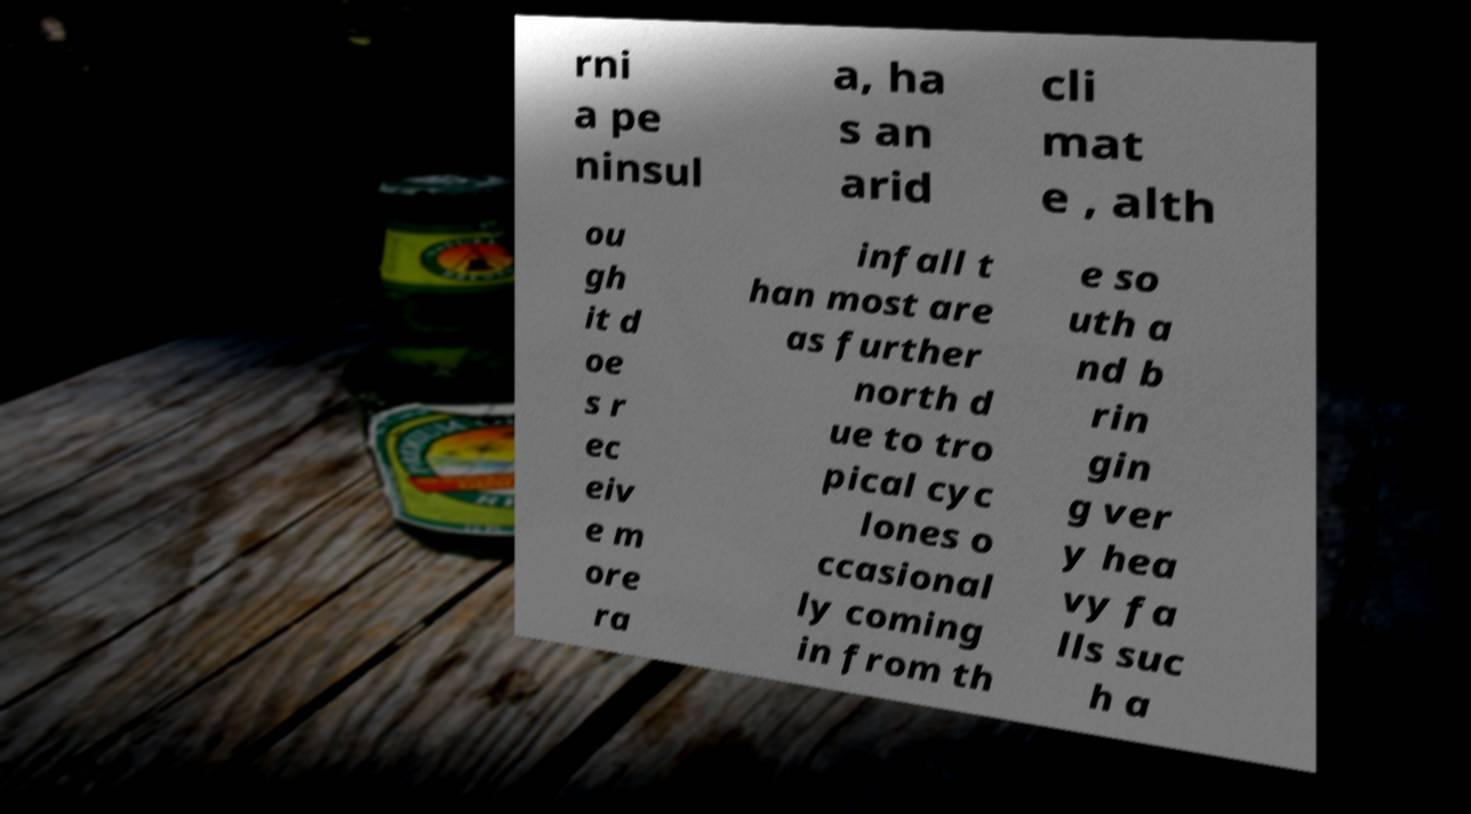What messages or text are displayed in this image? I need them in a readable, typed format. rni a pe ninsul a, ha s an arid cli mat e , alth ou gh it d oe s r ec eiv e m ore ra infall t han most are as further north d ue to tro pical cyc lones o ccasional ly coming in from th e so uth a nd b rin gin g ver y hea vy fa lls suc h a 